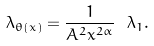<formula> <loc_0><loc_0><loc_500><loc_500>\lambda _ { \theta ( x ) } = \frac { 1 } { A ^ { 2 } x ^ { 2 \alpha } } \ \lambda _ { 1 } .</formula> 